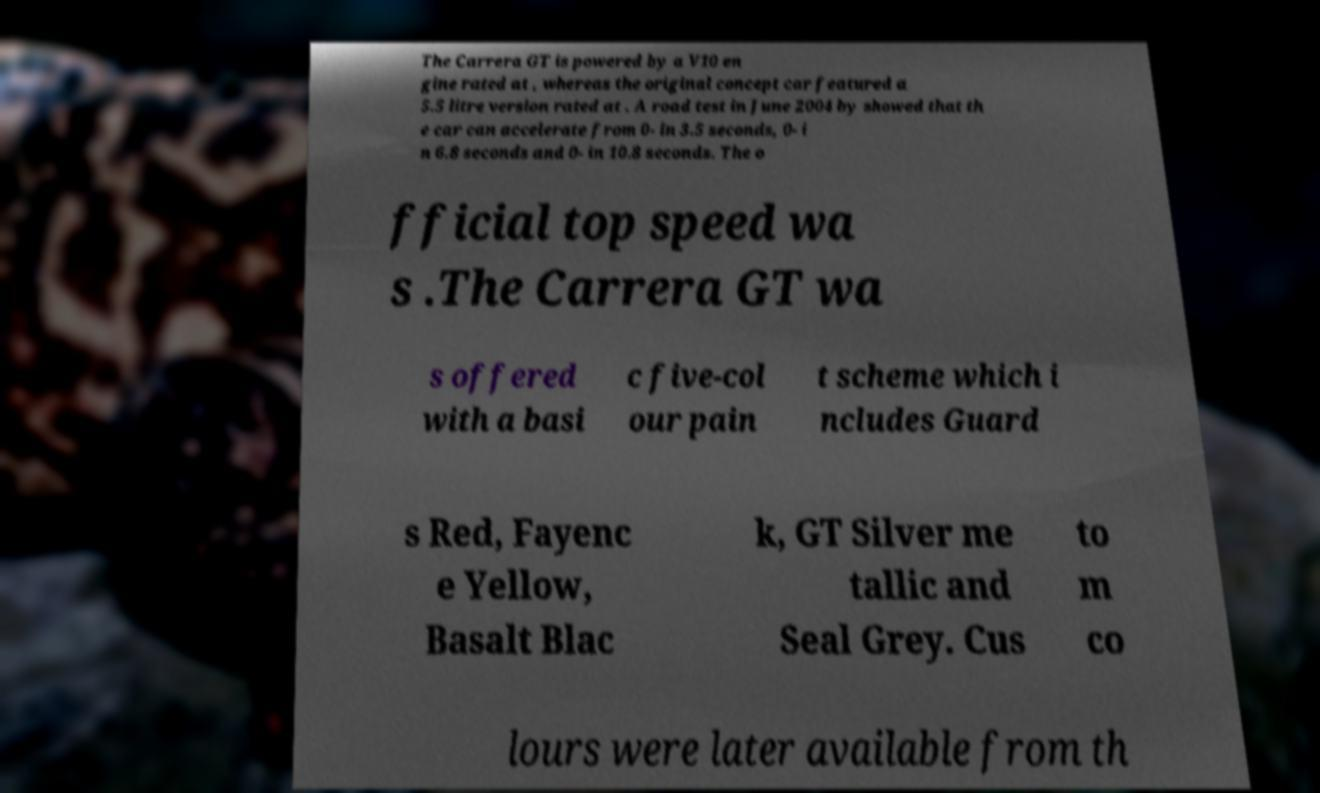Can you read and provide the text displayed in the image?This photo seems to have some interesting text. Can you extract and type it out for me? The Carrera GT is powered by a V10 en gine rated at , whereas the original concept car featured a 5.5 litre version rated at . A road test in June 2004 by showed that th e car can accelerate from 0- in 3.5 seconds, 0- i n 6.8 seconds and 0- in 10.8 seconds. The o fficial top speed wa s .The Carrera GT wa s offered with a basi c five-col our pain t scheme which i ncludes Guard s Red, Fayenc e Yellow, Basalt Blac k, GT Silver me tallic and Seal Grey. Cus to m co lours were later available from th 